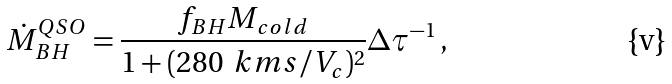Convert formula to latex. <formula><loc_0><loc_0><loc_500><loc_500>\dot { M } _ { B H } ^ { Q S O } = \frac { f _ { B H } M _ { c o l d } } { 1 + ( 2 8 0 \, \ k m s / V _ { c } ) ^ { 2 } } \Delta \tau ^ { - 1 } \, ,</formula> 